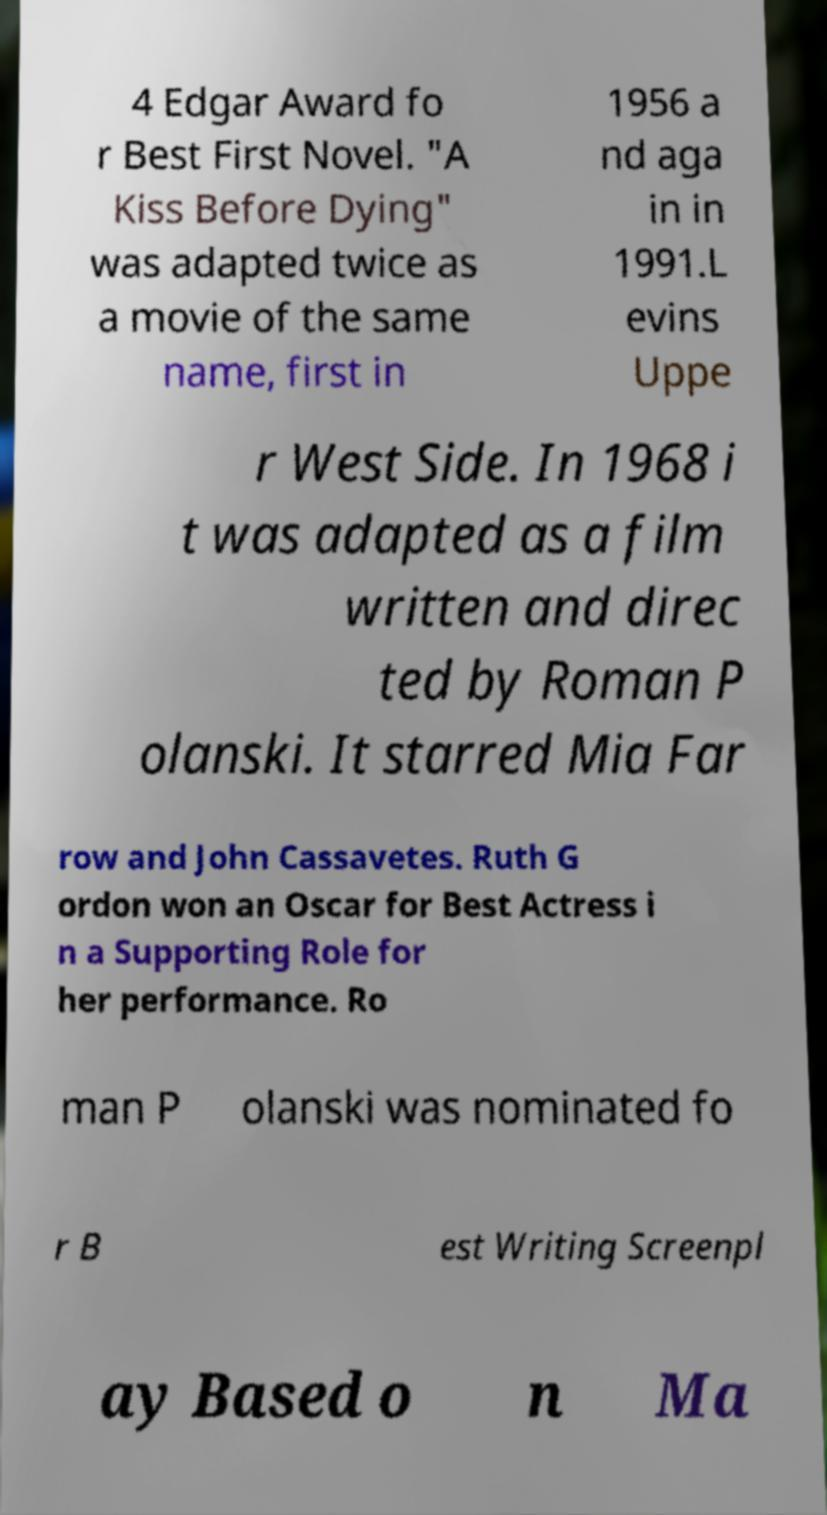Please identify and transcribe the text found in this image. 4 Edgar Award fo r Best First Novel. "A Kiss Before Dying" was adapted twice as a movie of the same name, first in 1956 a nd aga in in 1991.L evins Uppe r West Side. In 1968 i t was adapted as a film written and direc ted by Roman P olanski. It starred Mia Far row and John Cassavetes. Ruth G ordon won an Oscar for Best Actress i n a Supporting Role for her performance. Ro man P olanski was nominated fo r B est Writing Screenpl ay Based o n Ma 